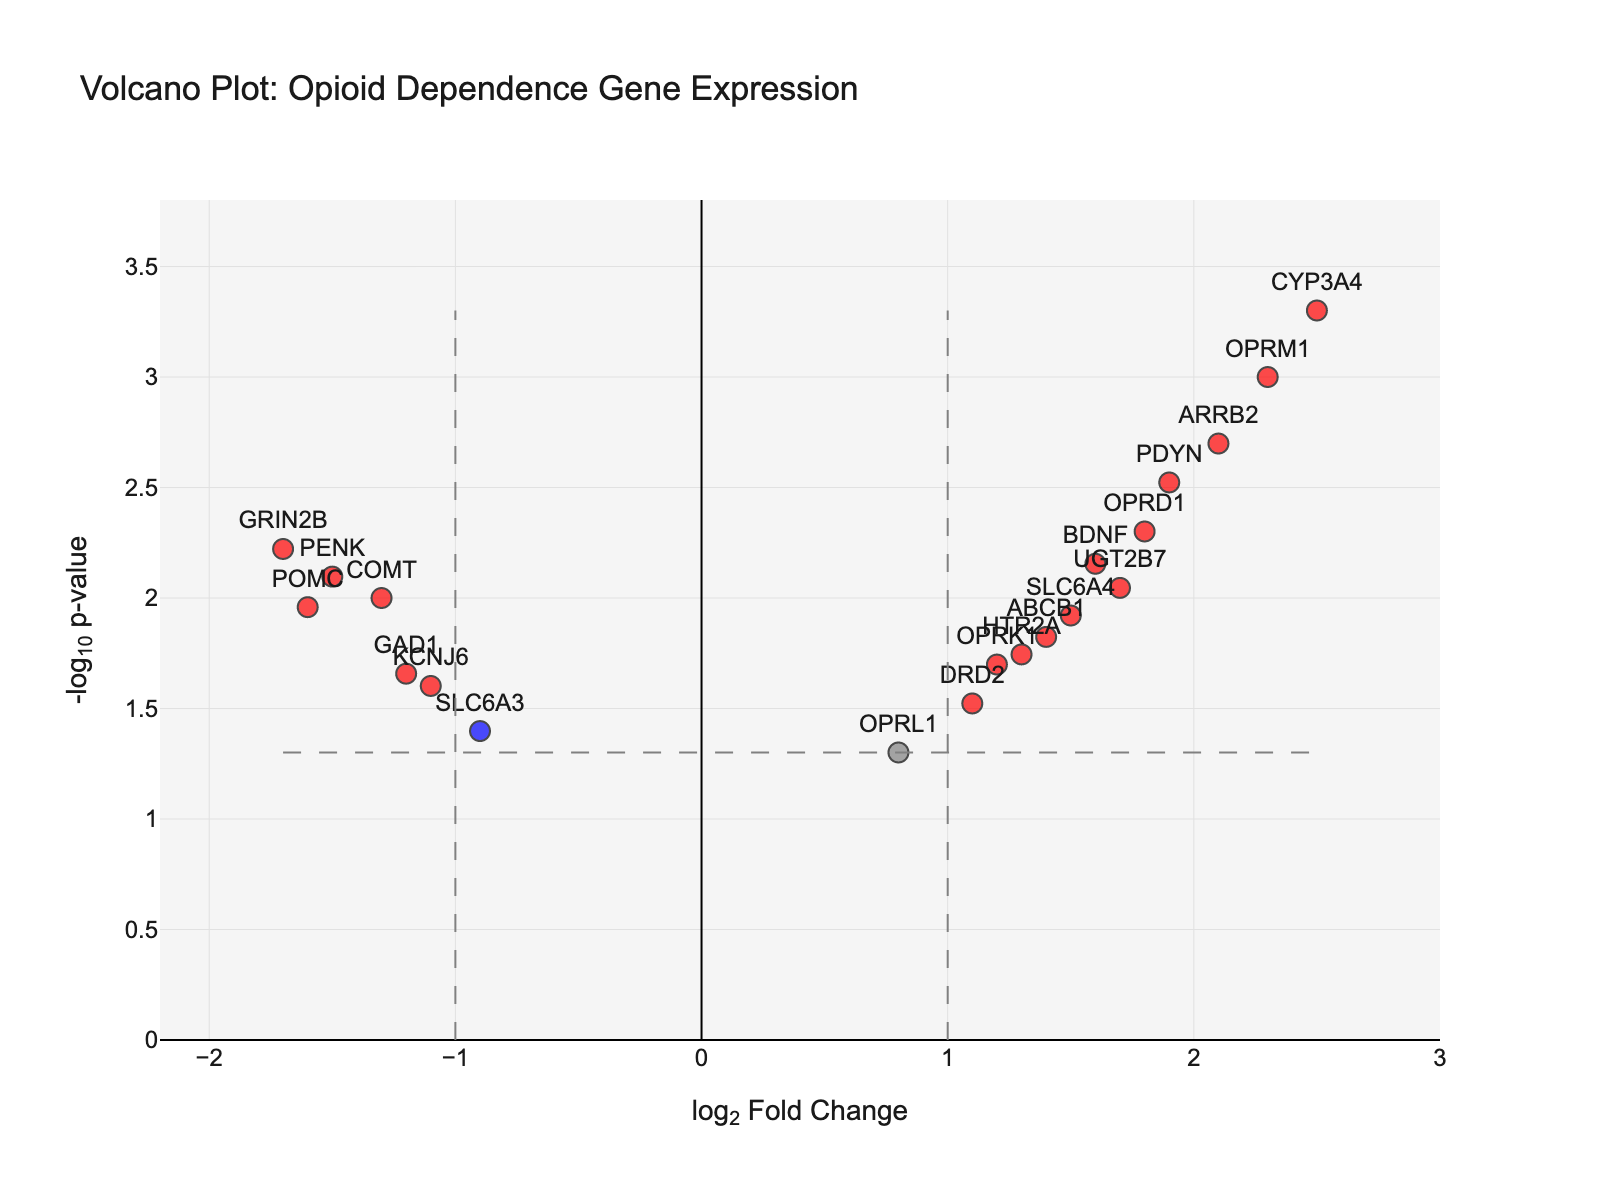What is the title of the plot? The title is located at the top of the plot and directly indicates the subject matter. In this plot, it reads: "Volcano Plot: Opioid Dependence Gene Expression".
Answer: Volcano Plot: Opioid Dependence Gene Expression How are the axes labeled? The labels for the axes can typically be found near the axis lines. For this plot, the x-axis is labeled "log2 Fold Change," and the y-axis is labeled "-log10 p-value".
Answer: log2 Fold Change (x-axis), -log10 p-value (y-axis) Which genes are highlighted in red, indicating significant fold changes and low p-values? Genes highlighted in red are those that meet the criteria of having an absolute log2 fold change greater than 1 and a p-value less than 0.05. Observing the red points on the plot, the genes are OPRM1, OPRD1, OPRK1, PDYN, BDNF, ARRB2, CYP3A4, ABCB1, UGT2B7, SLC6A4, and HTR2A.
Answer: OPRM1, OPRD1, OPRK1, PDYN, BDNF, ARRB2, CYP3A4, ABCB1, UGT2B7, SLC6A4, HTR2A What is the gene with the highest log2 fold change? To find the gene with the highest log2 fold change, look at the far right of the x-axis (positively distant from zero) within the plot. The gene at this position is CYP3A4, with a log2 fold change of 2.5.
Answer: CYP3A4 Which genes have the lowest p-values and how is this indicated in the plot? The lowest p-values can be found by identifying the highest points on the y-axis (since -log10(p-value) will be larger). Observing the vertical positioning, the genes with the highest points are CYP3A4, OPRM1, ARRB2, and PDYN.
Answer: CYP3A4, OPRM1, ARRB2, PDYN How many genes have a log2 fold change above 1 and a p-value below 0.05? Genes that fall into this category are marked in red and appear to the right of the vertical threshold line at log2FC of 1. Counting these points, there are 10 such genes.
Answer: 10 Which gene has the nearest log2 fold change to zero but still has a p-value below 0.05? The gene closest to zero on the x-axis but still below the dashed horizontal p-value threshold line is OPRL1, with a log2 fold change of 0.8.
Answer: OPRL1 Are there genes with significant negative log2 fold changes? Genes with significant negative log2 fold changes are those left of the vertical threshold line at log2FC of -1 and are colored red. Observing the plot, no genes meet this criterion.
Answer: No 